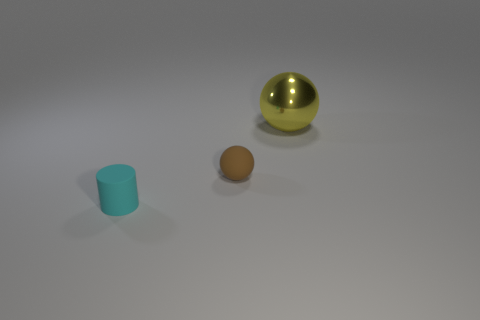Is the number of large shiny spheres that are left of the yellow ball greater than the number of small cylinders? The image shows only one large shiny sphere, which is gold-colored, and it is positioned to the right of the yellow ball instead of the left. To the left of the yellow ball, there are no spheres; instead, there is only a single small cylinder. Therefore, the answer is no, as there are no large shiny spheres left of the yellow ball to compare with the number of small cylinders. 